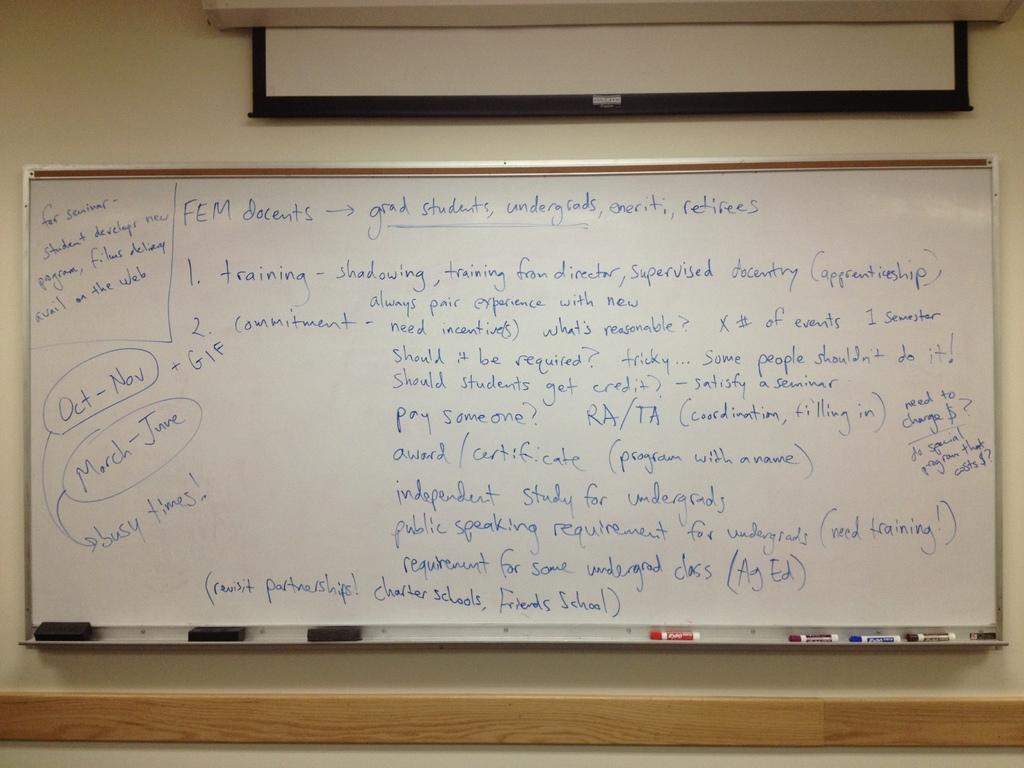<image>
Relay a brief, clear account of the picture shown. A dry erase board has a lot of notes on it and one indicates that Oct - Nov is one of the busy times. 